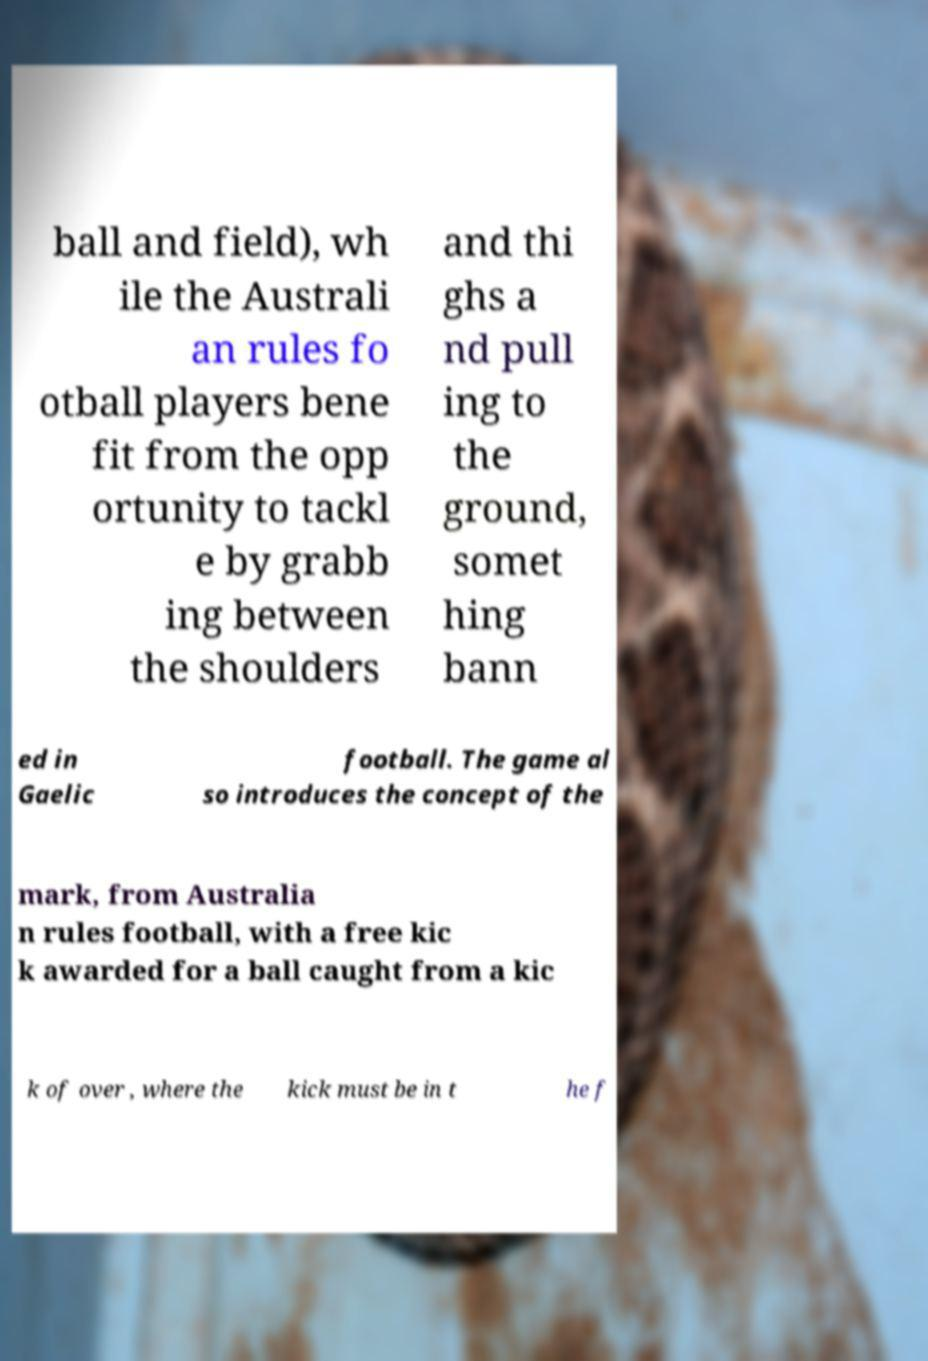Could you assist in decoding the text presented in this image and type it out clearly? ball and field), wh ile the Australi an rules fo otball players bene fit from the opp ortunity to tackl e by grabb ing between the shoulders and thi ghs a nd pull ing to the ground, somet hing bann ed in Gaelic football. The game al so introduces the concept of the mark, from Australia n rules football, with a free kic k awarded for a ball caught from a kic k of over , where the kick must be in t he f 